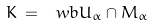Convert formula to latex. <formula><loc_0><loc_0><loc_500><loc_500>K \, = \, \ w b { U _ { \alpha } \cap M _ { \alpha } }</formula> 